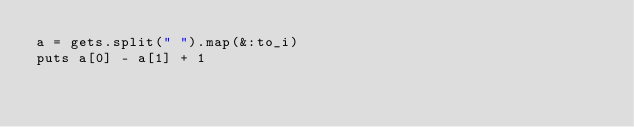Convert code to text. <code><loc_0><loc_0><loc_500><loc_500><_Ruby_>a = gets.split(" ").map(&:to_i)
puts a[0] - a[1] + 1</code> 